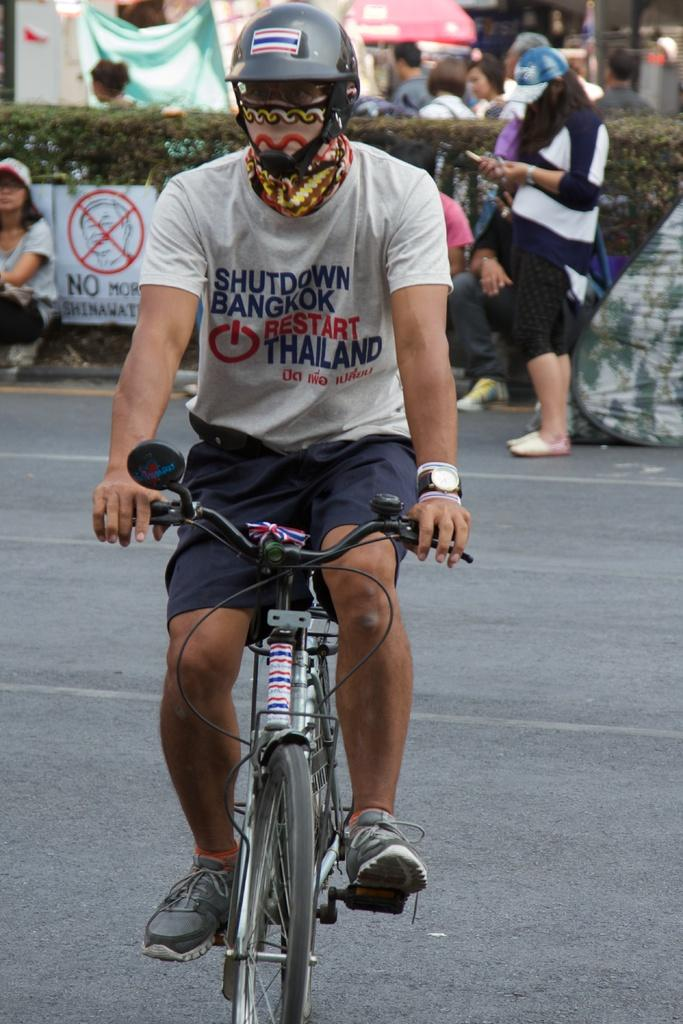What type of living organisms can be seen in the image? Plants are visible in the image. What additional object can be seen in the image? There is a banner in the image. What activity is the man in the image engaged in? The man is riding a bicycle in the image. Can you describe the background of the image? There are people visible in the background of the image. What type of drum can be seen in the image? There is no drum present in the image. What color is the tail of the man riding the bicycle in the image? The man riding the bicycle does not have a tail, so this question cannot be answered. 